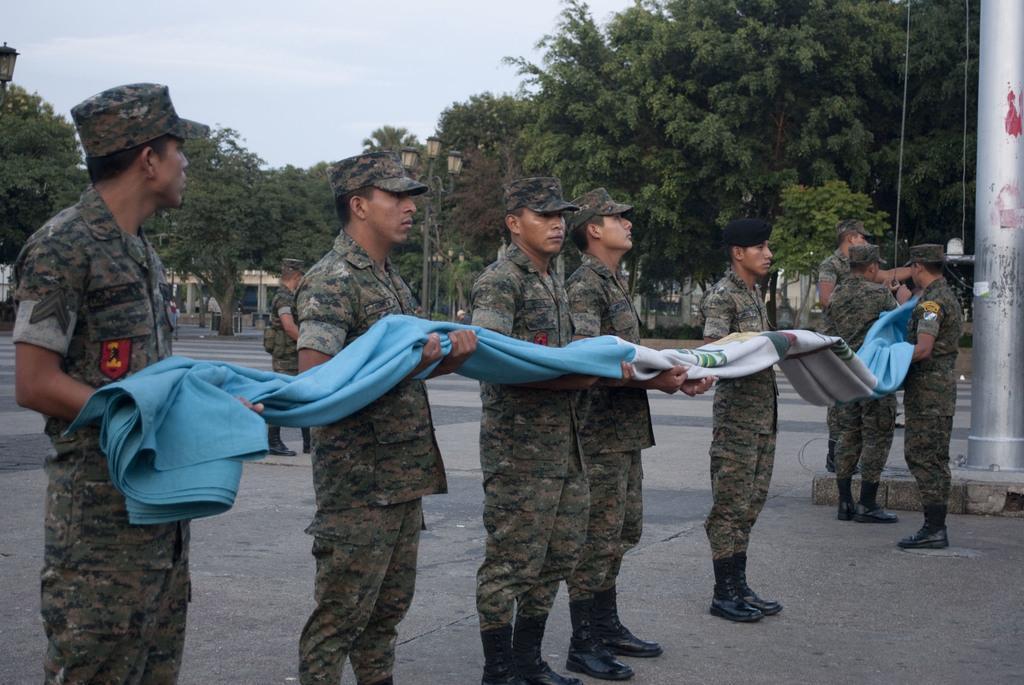Could you give a brief overview of what you see in this image? In this image there are some persons standing and holding a flag cloth in middle of this image and there is a flag pole at right side of this image and there are some trees in the background and there is a current pole in middle of this image and there is a sky at top of this image. 